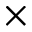<formula> <loc_0><loc_0><loc_500><loc_500>\times</formula> 